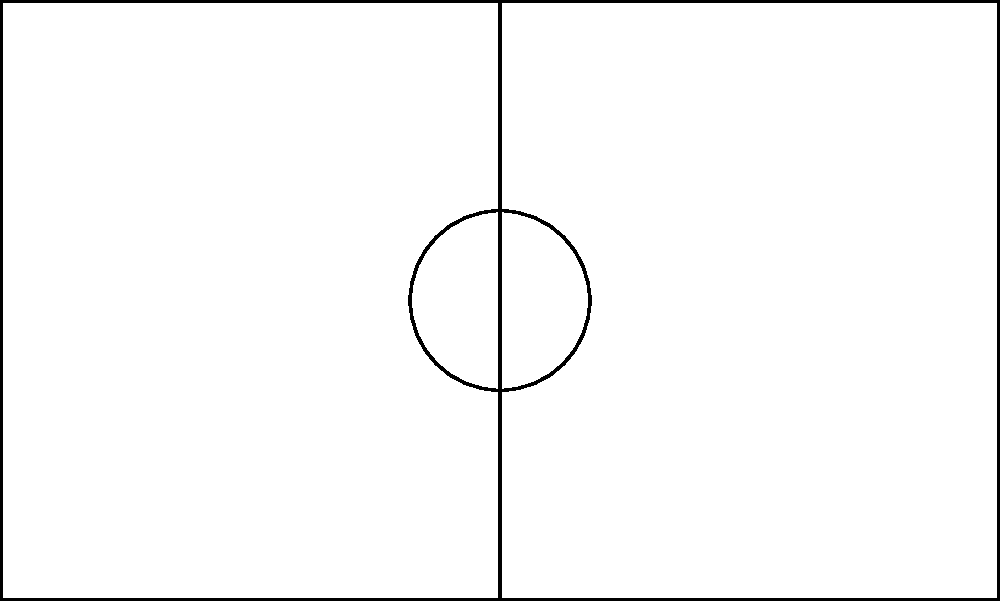In a soccer match, you're tasked with plotting player positions on a coordinate system. The field is represented on a coordinate plane where the center of the field is at (0,0), and each unit represents 1 meter. A forward (F) is positioned at (30,20), a defender (D) at (-10,-15), and a midfielder (M) at (0,0). What is the distance between the forward and the defender? To find the distance between two points on a coordinate plane, we can use the distance formula:

$$ d = \sqrt{(x_2 - x_1)^2 + (y_2 - y_1)^2} $$

Where $(x_1, y_1)$ is the position of the first point and $(x_2, y_2)$ is the position of the second point.

Let's follow these steps:

1. Identify the coordinates:
   Forward (F): $(x_1, y_1) = (30, 20)$
   Defender (D): $(x_2, y_2) = (-10, -15)$

2. Plug these values into the distance formula:
   $$ d = \sqrt{(-10 - 30)^2 + (-15 - 20)^2} $$

3. Simplify inside the parentheses:
   $$ d = \sqrt{(-40)^2 + (-35)^2} $$

4. Calculate the squares:
   $$ d = \sqrt{1600 + 1225} $$

5. Add inside the square root:
   $$ d = \sqrt{2825} $$

6. Calculate the square root:
   $$ d \approx 53.15 $$

Therefore, the distance between the forward and the defender is approximately 53.15 meters.
Answer: 53.15 meters 